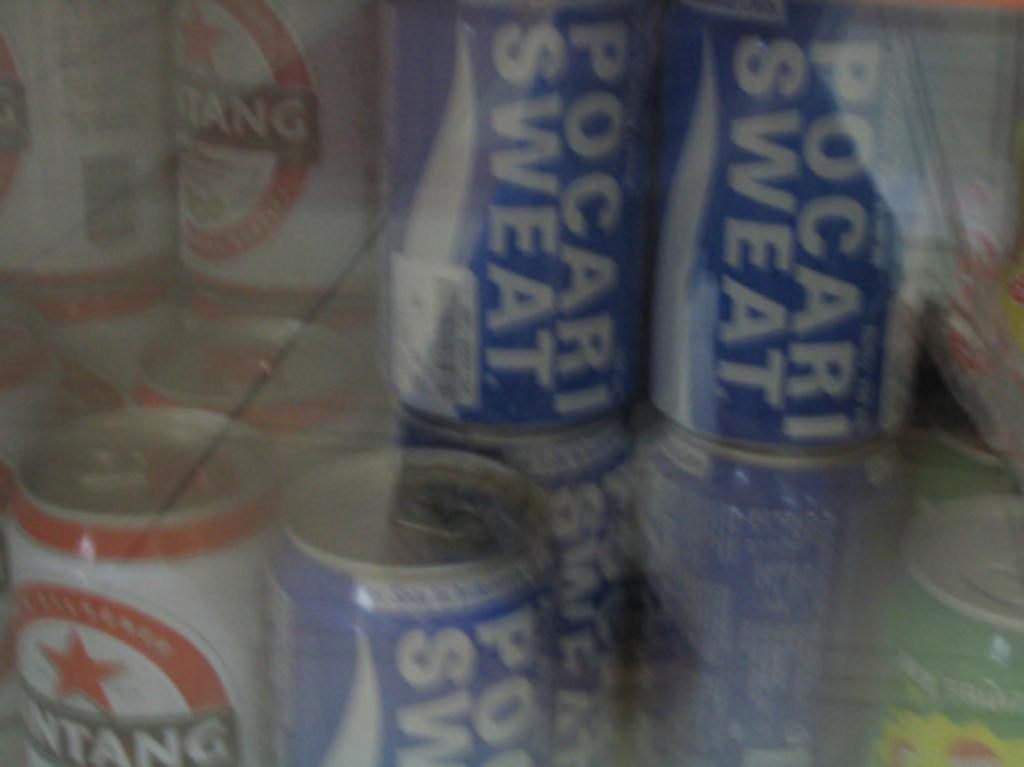<image>
Present a compact description of the photo's key features. a pocari word on some cans that are blue 